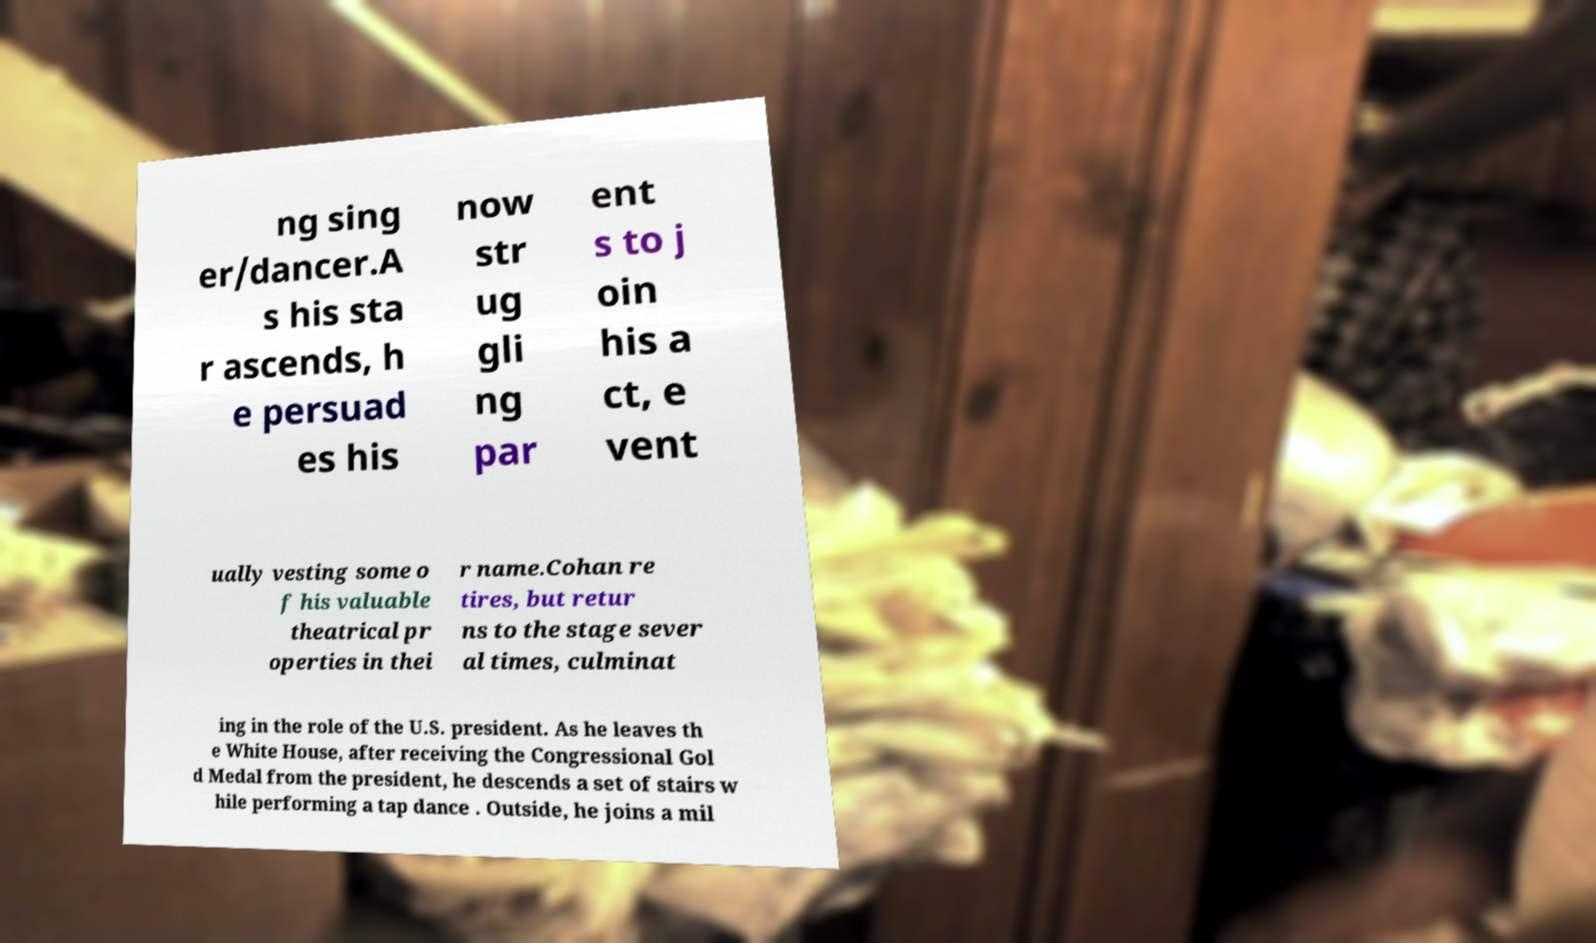For documentation purposes, I need the text within this image transcribed. Could you provide that? ng sing er/dancer.A s his sta r ascends, h e persuad es his now str ug gli ng par ent s to j oin his a ct, e vent ually vesting some o f his valuable theatrical pr operties in thei r name.Cohan re tires, but retur ns to the stage sever al times, culminat ing in the role of the U.S. president. As he leaves th e White House, after receiving the Congressional Gol d Medal from the president, he descends a set of stairs w hile performing a tap dance . Outside, he joins a mil 